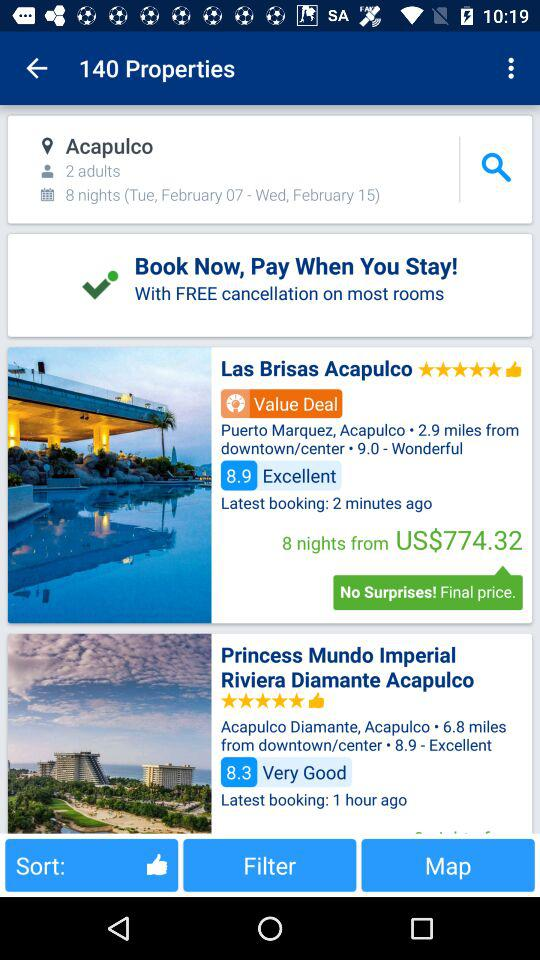How much is the price for 8 nights at "Las Brisas Acapulco" property? The price is 774.32 US dollars. 